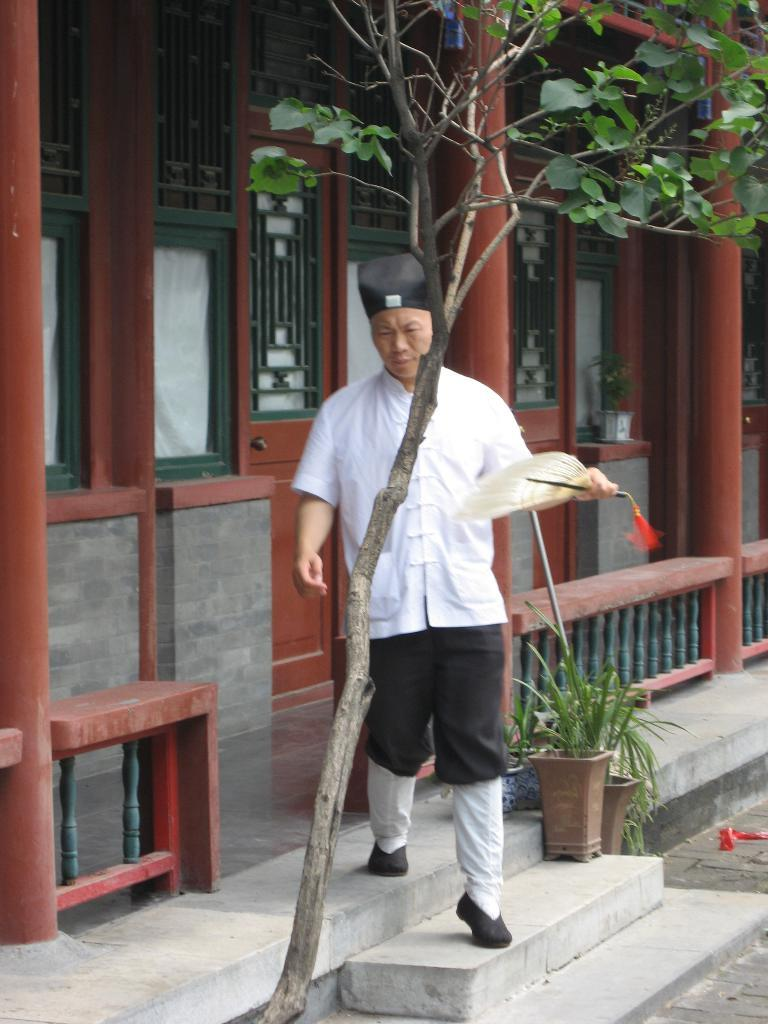What structure can be seen in the image? There is a building in the image. What is the person in the image doing? The person is walking in the image. What is the person holding in their hands? The person is holding an object in their hands. What type of decorative items are present in the image? There are flower pots in the image. What type of plant can be seen in the image? There is a tree in the image. Can you see any fairies flying around the tree in the image? There are no fairies present in the image. What type of canvas is used to create the building in the image? The building in the image is a real structure, not a painting or drawing, so there is no canvas involved. 